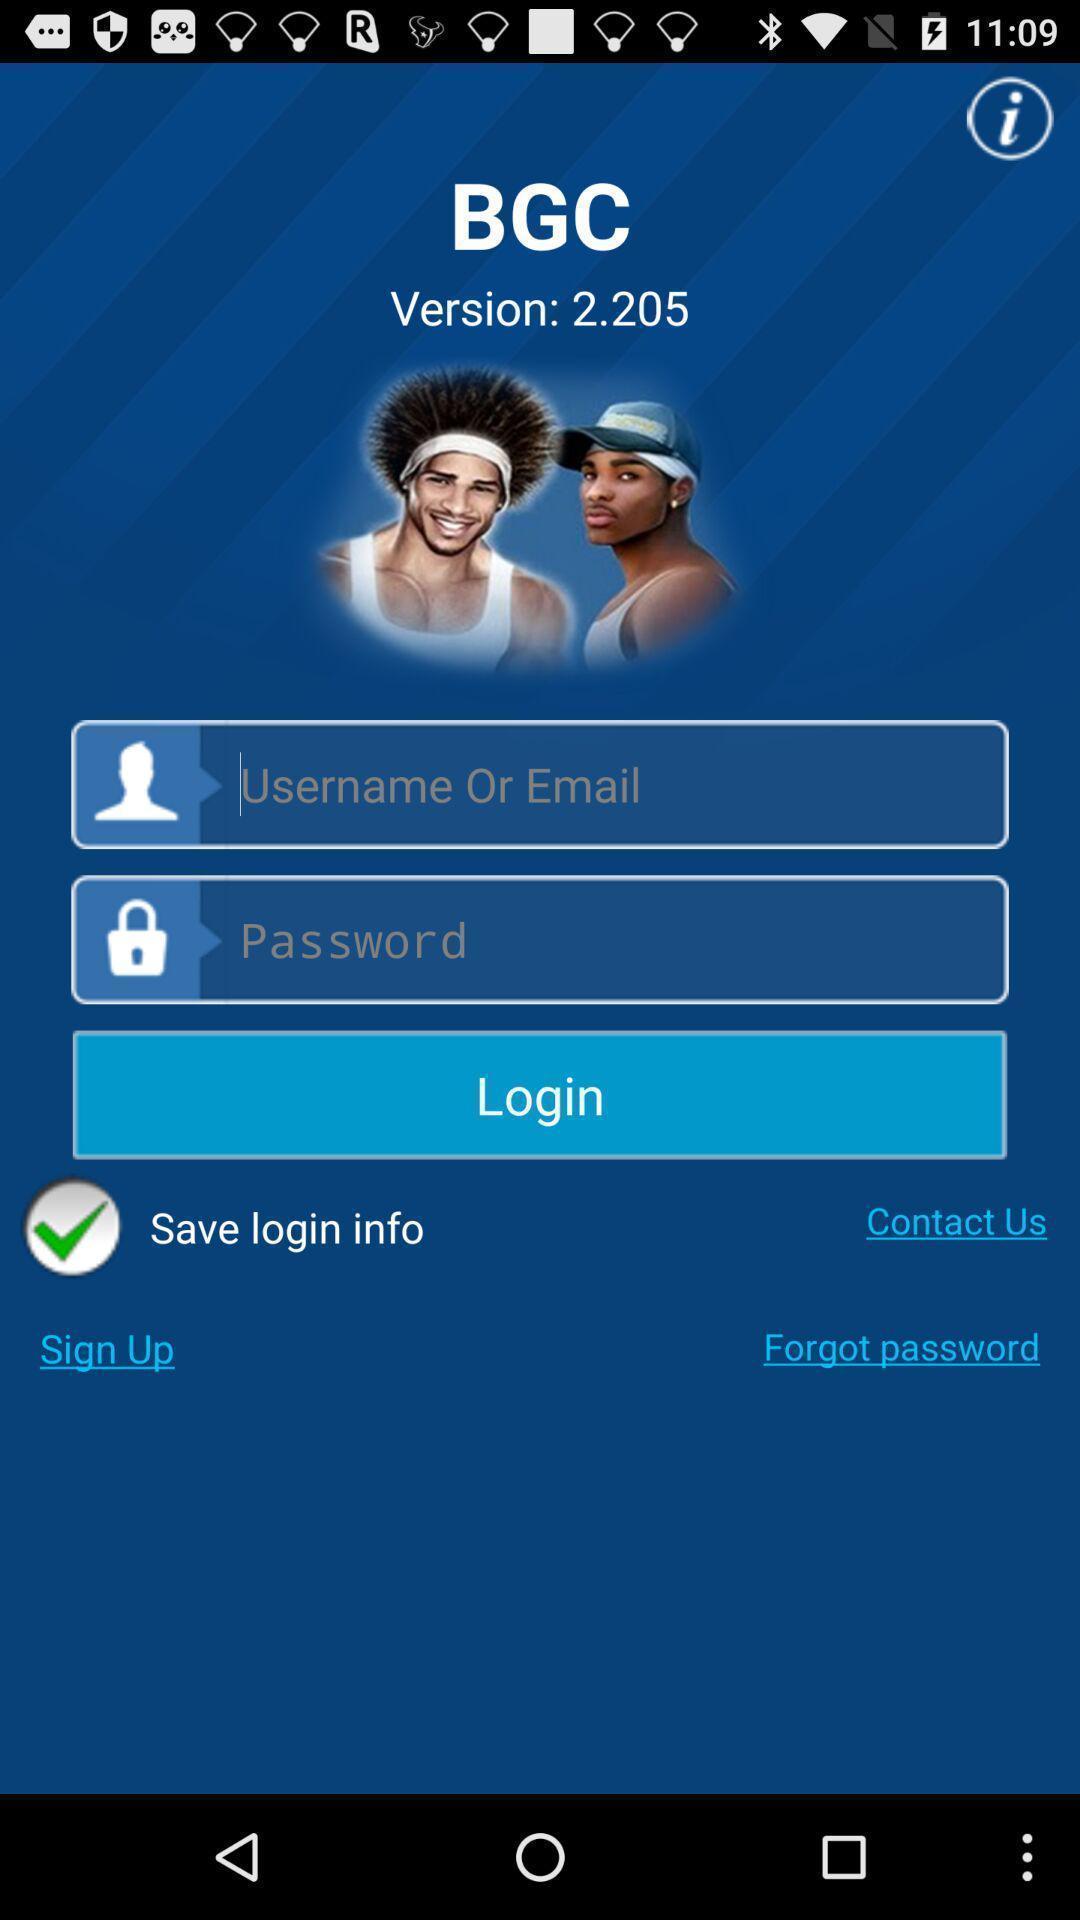Describe the content in this image. Login page. 